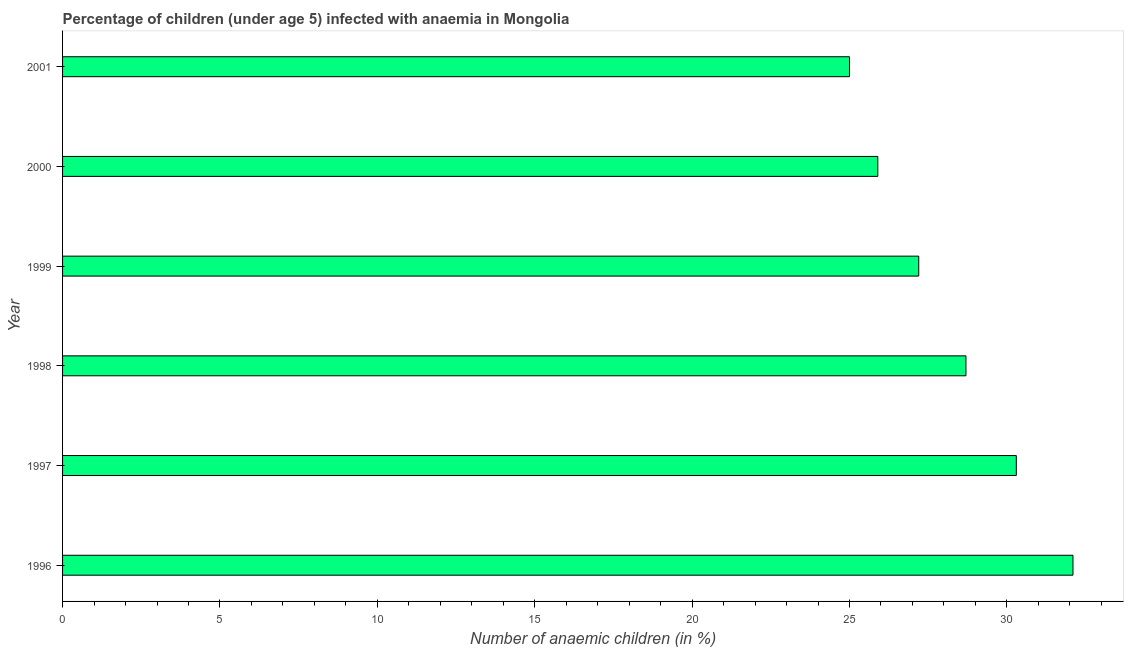Does the graph contain any zero values?
Provide a short and direct response. No. What is the title of the graph?
Offer a terse response. Percentage of children (under age 5) infected with anaemia in Mongolia. What is the label or title of the X-axis?
Offer a very short reply. Number of anaemic children (in %). What is the label or title of the Y-axis?
Make the answer very short. Year. What is the number of anaemic children in 2000?
Give a very brief answer. 25.9. Across all years, what is the maximum number of anaemic children?
Provide a short and direct response. 32.1. Across all years, what is the minimum number of anaemic children?
Offer a terse response. 25. In which year was the number of anaemic children maximum?
Give a very brief answer. 1996. In which year was the number of anaemic children minimum?
Make the answer very short. 2001. What is the sum of the number of anaemic children?
Give a very brief answer. 169.2. What is the average number of anaemic children per year?
Make the answer very short. 28.2. What is the median number of anaemic children?
Provide a succinct answer. 27.95. In how many years, is the number of anaemic children greater than 30 %?
Your answer should be very brief. 2. What is the ratio of the number of anaemic children in 1996 to that in 2000?
Your answer should be compact. 1.24. Is the number of anaemic children in 1996 less than that in 1997?
Provide a succinct answer. No. What is the difference between the highest and the lowest number of anaemic children?
Your response must be concise. 7.1. In how many years, is the number of anaemic children greater than the average number of anaemic children taken over all years?
Offer a very short reply. 3. Are all the bars in the graph horizontal?
Provide a short and direct response. Yes. Are the values on the major ticks of X-axis written in scientific E-notation?
Offer a very short reply. No. What is the Number of anaemic children (in %) in 1996?
Your answer should be very brief. 32.1. What is the Number of anaemic children (in %) in 1997?
Provide a succinct answer. 30.3. What is the Number of anaemic children (in %) of 1998?
Offer a very short reply. 28.7. What is the Number of anaemic children (in %) of 1999?
Provide a short and direct response. 27.2. What is the Number of anaemic children (in %) of 2000?
Offer a very short reply. 25.9. What is the difference between the Number of anaemic children (in %) in 1996 and 1999?
Offer a terse response. 4.9. What is the difference between the Number of anaemic children (in %) in 1996 and 2000?
Make the answer very short. 6.2. What is the difference between the Number of anaemic children (in %) in 1996 and 2001?
Ensure brevity in your answer.  7.1. What is the difference between the Number of anaemic children (in %) in 1997 and 1999?
Provide a succinct answer. 3.1. What is the difference between the Number of anaemic children (in %) in 1997 and 2000?
Offer a terse response. 4.4. What is the difference between the Number of anaemic children (in %) in 1997 and 2001?
Your answer should be compact. 5.3. What is the difference between the Number of anaemic children (in %) in 1998 and 2001?
Provide a short and direct response. 3.7. What is the difference between the Number of anaemic children (in %) in 1999 and 2000?
Provide a short and direct response. 1.3. What is the ratio of the Number of anaemic children (in %) in 1996 to that in 1997?
Your response must be concise. 1.06. What is the ratio of the Number of anaemic children (in %) in 1996 to that in 1998?
Offer a very short reply. 1.12. What is the ratio of the Number of anaemic children (in %) in 1996 to that in 1999?
Your answer should be very brief. 1.18. What is the ratio of the Number of anaemic children (in %) in 1996 to that in 2000?
Provide a short and direct response. 1.24. What is the ratio of the Number of anaemic children (in %) in 1996 to that in 2001?
Offer a very short reply. 1.28. What is the ratio of the Number of anaemic children (in %) in 1997 to that in 1998?
Provide a short and direct response. 1.06. What is the ratio of the Number of anaemic children (in %) in 1997 to that in 1999?
Your answer should be compact. 1.11. What is the ratio of the Number of anaemic children (in %) in 1997 to that in 2000?
Provide a succinct answer. 1.17. What is the ratio of the Number of anaemic children (in %) in 1997 to that in 2001?
Give a very brief answer. 1.21. What is the ratio of the Number of anaemic children (in %) in 1998 to that in 1999?
Provide a short and direct response. 1.05. What is the ratio of the Number of anaemic children (in %) in 1998 to that in 2000?
Ensure brevity in your answer.  1.11. What is the ratio of the Number of anaemic children (in %) in 1998 to that in 2001?
Offer a very short reply. 1.15. What is the ratio of the Number of anaemic children (in %) in 1999 to that in 2000?
Your answer should be very brief. 1.05. What is the ratio of the Number of anaemic children (in %) in 1999 to that in 2001?
Your answer should be compact. 1.09. What is the ratio of the Number of anaemic children (in %) in 2000 to that in 2001?
Make the answer very short. 1.04. 